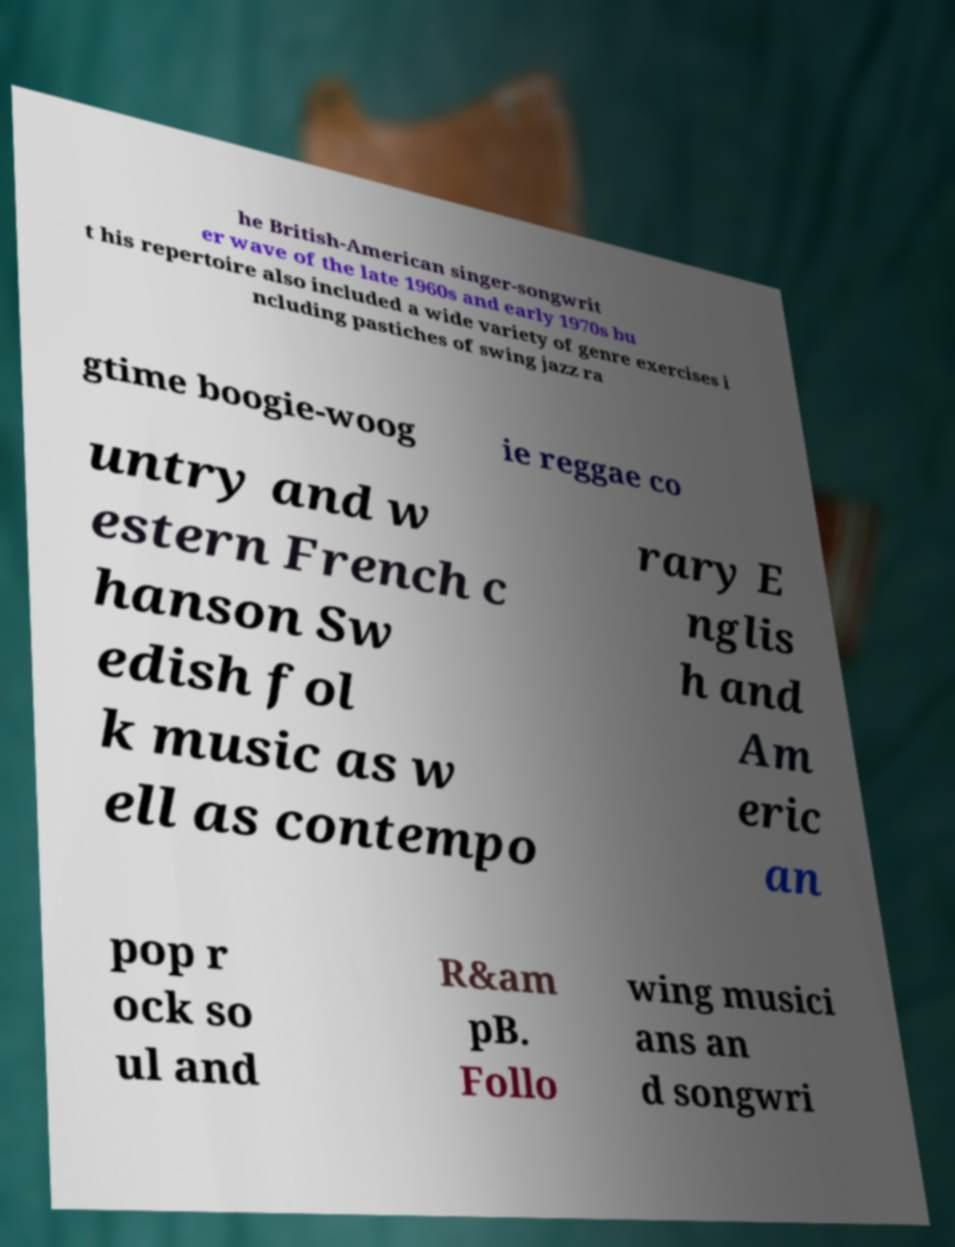Please identify and transcribe the text found in this image. he British-American singer-songwrit er wave of the late 1960s and early 1970s bu t his repertoire also included a wide variety of genre exercises i ncluding pastiches of swing jazz ra gtime boogie-woog ie reggae co untry and w estern French c hanson Sw edish fol k music as w ell as contempo rary E nglis h and Am eric an pop r ock so ul and R&am pB. Follo wing musici ans an d songwri 